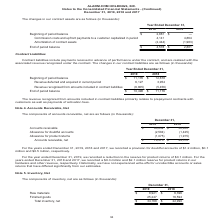According to Alarmcom Holdings's financial document, What was the amount of raw materials in 2019? According to the financial document, $8,921 (in thousands). The relevant text states: "December 31, 2019 2018 Raw materials $ 8,921 $ 6,396 Finished goods 25,247 16,594 Total inventory, net $ 34,168 $ 22,990..." Also, What was the amount of finished goods in 2018? According to the financial document, 16,594 (in thousands). The relevant text states: "w materials $ 8,921 $ 6,396 Finished goods 25,247 16,594 Total inventory, net $ 34,168 $ 22,990..." Also, Which years does the table provide information for net inventory? The document shows two values: 2019 and 2018. From the document: "Year Ended December 31, 2019 2018 Beginning of period balance $ 2,881 $ — Commission costs and upfront payments to a customer ca Year Ended December 3..." Also, can you calculate: What was the change in raw materials between 2018 and 2019? Based on the calculation: 8,921-6,396, the result is 2525 (in thousands). This is based on the information: "December 31, 2019 2018 Raw materials $ 8,921 $ 6,396 Finished goods 25,247 16,594 Total inventory, net $ 34,168 $ 22,990 December 31, 2019 2018 Raw materials $ 8,921 $ 6,396 Finished goods 25,247 16,5..." The key data points involved are: 6,396, 8,921. Also, can you calculate: What was the change in finished goods between 2018 and 2019? Based on the calculation: 25,247-16,594, the result is 8653 (in thousands). This is based on the information: "2018 Raw materials $ 8,921 $ 6,396 Finished goods 25,247 16,594 Total inventory, net $ 34,168 $ 22,990 w materials $ 8,921 $ 6,396 Finished goods 25,247 16,594 Total inventory, net $ 34,168 $ 22,990..." The key data points involved are: 16,594, 25,247. Also, can you calculate: What was the percentage change in the net total inventory between 2018 and 2019? To answer this question, I need to perform calculations using the financial data. The calculation is: (34,168-22,990)/22,990, which equals 48.62 (percentage). This is based on the information: "ods 25,247 16,594 Total inventory, net $ 34,168 $ 22,990 nished goods 25,247 16,594 Total inventory, net $ 34,168 $ 22,990..." The key data points involved are: 22,990, 34,168. 